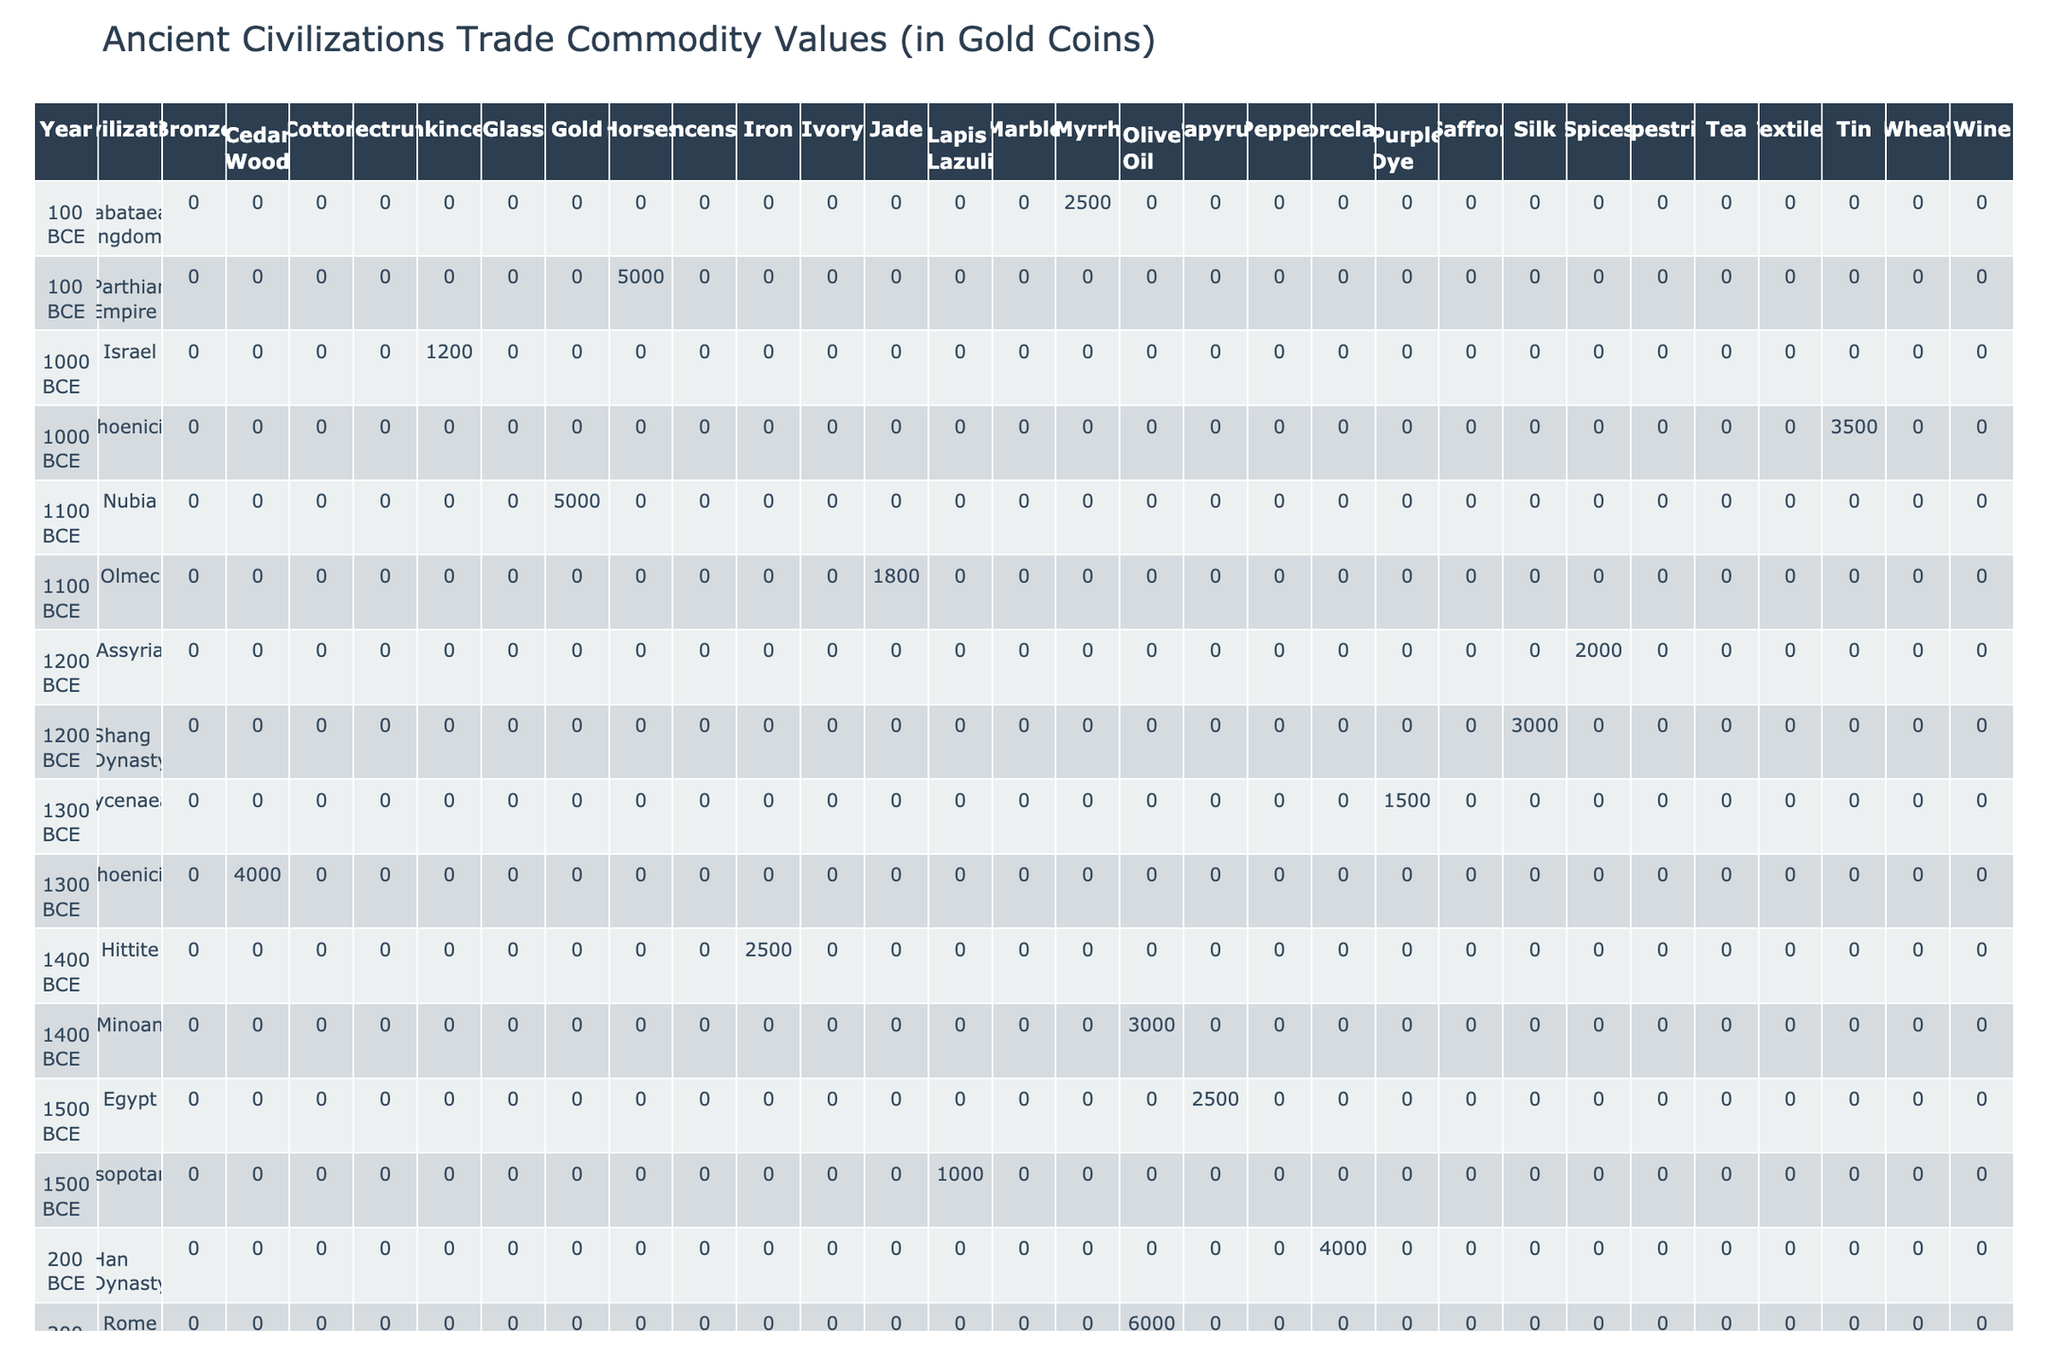What civilization traded the most valuable commodity in 500 BCE? In 500 BCE, the commodities traded included Marble by Rome valued at 5000 gold coins, and Cotton by India valued at 3500 gold coins. Since 5000 is greater than 3500, Rome traded the most valuable commodity in that year.
Answer: Rome Which trade route was used by the Nubian civilization in 1100 BCE? According to the table, the Nubian civilization used the Red Sea trade route in 1100 BCE.
Answer: Red Sea What is the total value of commodities traded by Greece in 700 BCE? Greece traded Wheat valued at 5000 gold coins in 700 BCE. Since this is the only entry for Greece in that year, the total value is 5000 gold coins.
Answer: 5000 Did the Parthian Empire trade any commodities in 100 BCE? The table shows that the Parthian Empire traded Horses valued at 5000 gold coins in 100 BCE. Therefore, yes, they traded commodities.
Answer: Yes What was the average value of commodities traded by Phoenicia throughout the table? Phoenicia appeared with the following values: Cedar Wood (4000), Tin (3500), and Glass (1500). The total value is 4000 + 3500 + 1500 = 9000, and there are 3 entries. The average value is 9000 / 3 = 3000.
Answer: 3000 Which civilization had the least quantity of commodities traded in 1100 BCE? In 1100 BCE, the commodities traded were Jade (150 pieces) by the Olmec and Gold (50 ingots) by Nubia. The Nubian quantity of 50 is less than the Olmec's 150, so Nubia had the least quantity traded.
Answer: Nubia In which year did the Minoan civilization trade Olive Oil, and how much was it valued? The Minoan civilization traded Olive Oil in 1400 BCE, with a value of 3000 gold coins.
Answer: 1400 BCE, 3000 gold coins What was the total value of commodities traded by China during the period shown? China traded Tea valued at 2000 gold coins in 400 BCE. Since this is the only entry for China, the total value of commodities traded is 2000 gold coins.
Answer: 2000 Which civilization used the Silk Road for trading in both 400 BCE and 100 BCE? The table indicates that both the Han Dynasty (200 BCE) and the Parthian Empire (100 BCE) are associated with the Silk Road, but since 400 BCE records China trading on the Silk Road for the first time, only the Parthian Empire matches the requirement of trading on the Silk Road in both years.
Answer: Parthian Empire 